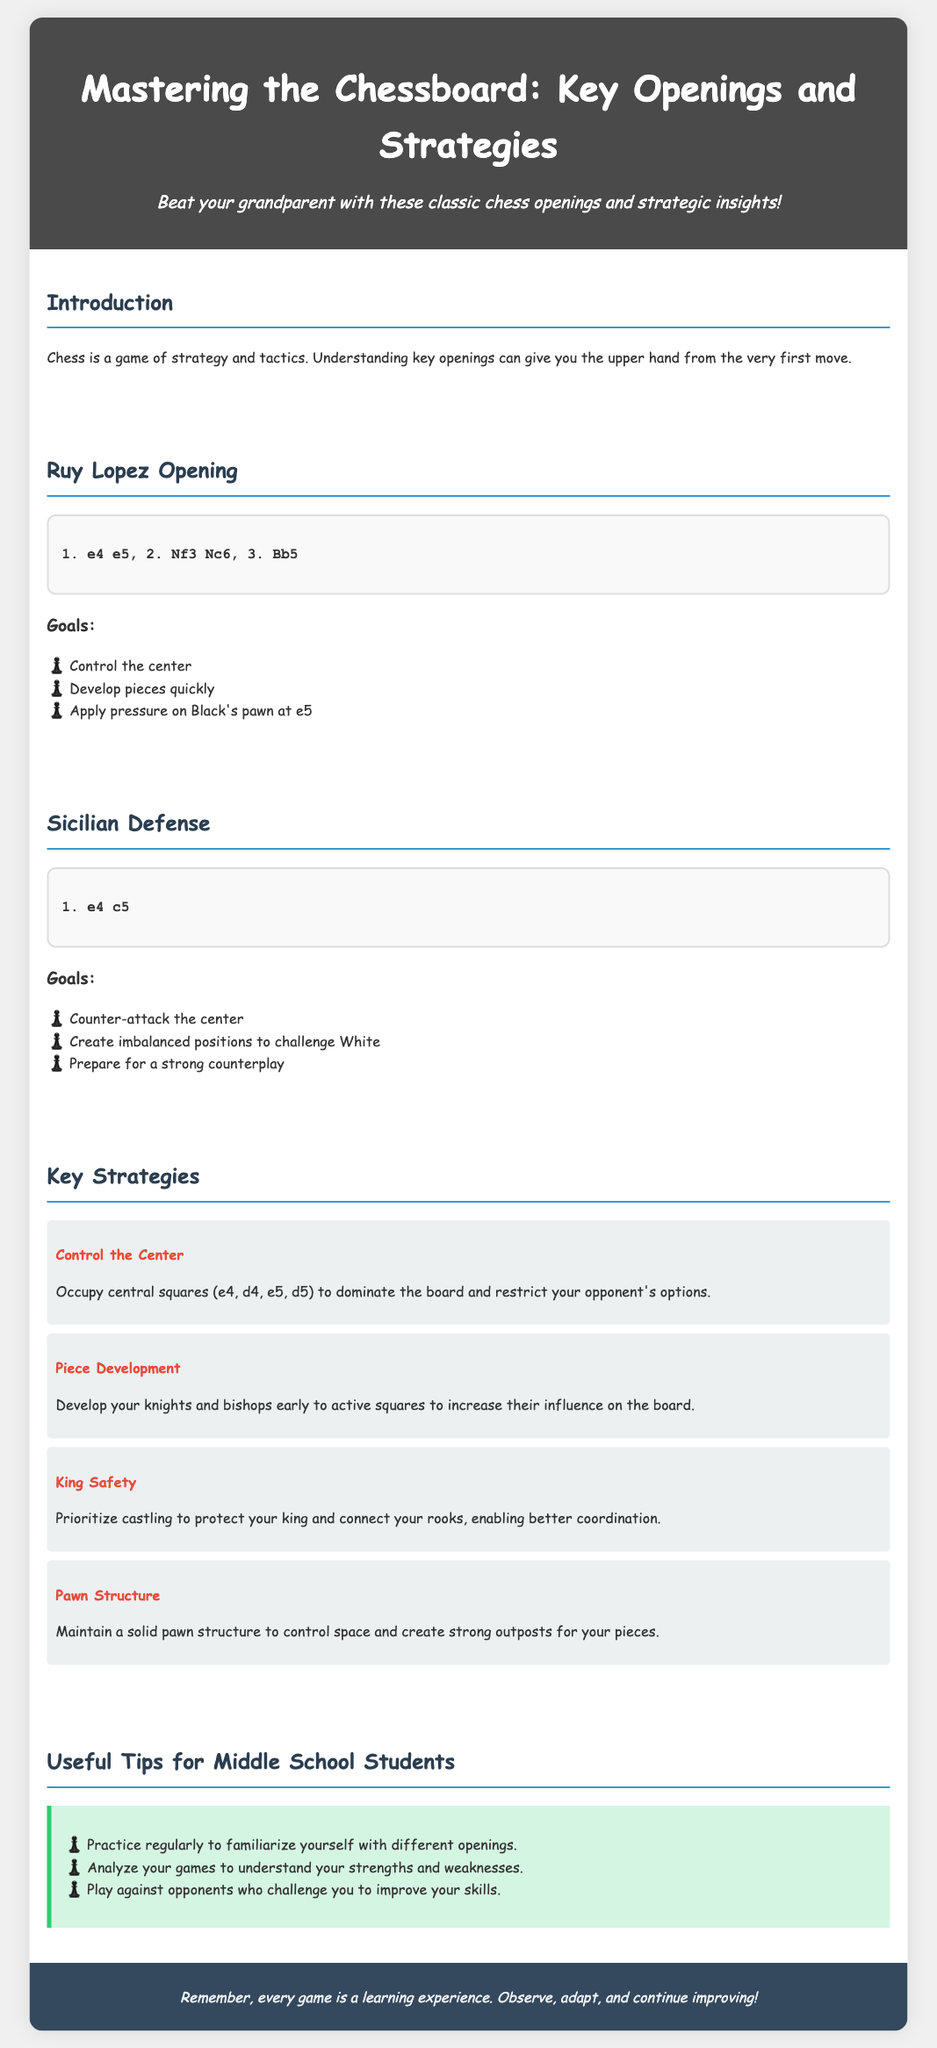what is the title of the infographic? The title of the infographic is prominently displayed at the top, which is "Mastering the Chessboard: Key Openings and Strategies."
Answer: Mastering the Chessboard: Key Openings and Strategies what is the first move of the Ruy Lopez opening? The first move of the Ruy Lopez opening is listed in the move sequence, which is "e4."
Answer: e4 what are the goals of the Sicilian Defense? The goals of the Sicilian Defense are presented as a list within the section, which includes counter-attacking the center among others.
Answer: Counter-attack the center how many key strategies are outlined in the infographic? The number of key strategies can be counted from the section providing that information, which contains four strategies.
Answer: Four which piece is developed in the Ruy Lopez opening? The Ruy Lopez opening includes the development of the bishop on the move "3. Bb5."
Answer: Bishop what type of tips are provided for middle school students? The tips section specifically focuses on providing advice for middle school students about improving skills in chess.
Answer: Useful Tips for Middle School Students what color is the background of the document? The background color of the document's body is light grey, which is indicated in the style section.
Answer: Light grey what is a key strategy for king safety? The specific action that relates to king safety is prioritized in the key strategies section where it mentions castling.
Answer: Castling 